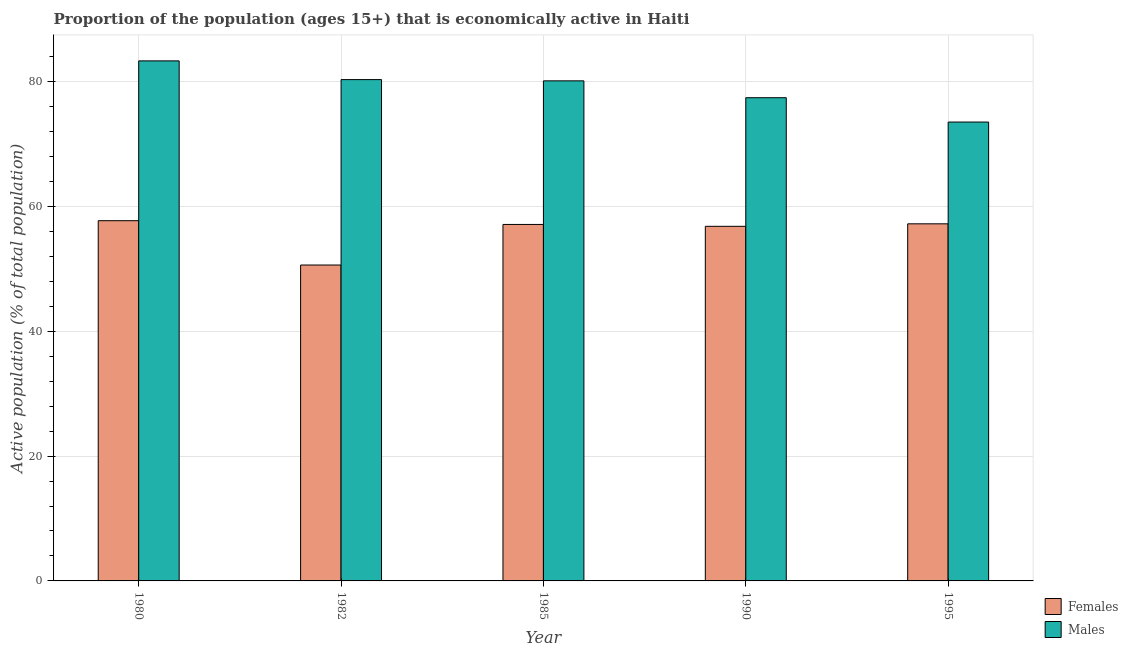How many different coloured bars are there?
Keep it short and to the point. 2. How many groups of bars are there?
Provide a succinct answer. 5. Are the number of bars per tick equal to the number of legend labels?
Offer a very short reply. Yes. Are the number of bars on each tick of the X-axis equal?
Your answer should be very brief. Yes. What is the label of the 4th group of bars from the left?
Your response must be concise. 1990. In how many cases, is the number of bars for a given year not equal to the number of legend labels?
Offer a very short reply. 0. What is the percentage of economically active female population in 1980?
Ensure brevity in your answer.  57.7. Across all years, what is the maximum percentage of economically active female population?
Your response must be concise. 57.7. Across all years, what is the minimum percentage of economically active female population?
Give a very brief answer. 50.6. In which year was the percentage of economically active female population maximum?
Your answer should be compact. 1980. What is the total percentage of economically active female population in the graph?
Your response must be concise. 279.4. What is the difference between the percentage of economically active male population in 1995 and the percentage of economically active female population in 1980?
Your response must be concise. -9.8. What is the average percentage of economically active female population per year?
Provide a short and direct response. 55.88. In the year 1985, what is the difference between the percentage of economically active male population and percentage of economically active female population?
Give a very brief answer. 0. In how many years, is the percentage of economically active male population greater than 60 %?
Your response must be concise. 5. What is the ratio of the percentage of economically active female population in 1982 to that in 1990?
Keep it short and to the point. 0.89. Is the percentage of economically active male population in 1980 less than that in 1985?
Ensure brevity in your answer.  No. What is the difference between the highest and the lowest percentage of economically active female population?
Make the answer very short. 7.1. What does the 1st bar from the left in 1995 represents?
Keep it short and to the point. Females. What does the 2nd bar from the right in 1990 represents?
Ensure brevity in your answer.  Females. How many bars are there?
Keep it short and to the point. 10. What is the difference between two consecutive major ticks on the Y-axis?
Your response must be concise. 20. Are the values on the major ticks of Y-axis written in scientific E-notation?
Your answer should be compact. No. Does the graph contain any zero values?
Give a very brief answer. No. Where does the legend appear in the graph?
Your response must be concise. Bottom right. How are the legend labels stacked?
Provide a succinct answer. Vertical. What is the title of the graph?
Offer a terse response. Proportion of the population (ages 15+) that is economically active in Haiti. What is the label or title of the Y-axis?
Your response must be concise. Active population (% of total population). What is the Active population (% of total population) in Females in 1980?
Provide a short and direct response. 57.7. What is the Active population (% of total population) of Males in 1980?
Your answer should be very brief. 83.3. What is the Active population (% of total population) of Females in 1982?
Provide a short and direct response. 50.6. What is the Active population (% of total population) of Males in 1982?
Give a very brief answer. 80.3. What is the Active population (% of total population) of Females in 1985?
Ensure brevity in your answer.  57.1. What is the Active population (% of total population) in Males in 1985?
Keep it short and to the point. 80.1. What is the Active population (% of total population) in Females in 1990?
Ensure brevity in your answer.  56.8. What is the Active population (% of total population) in Males in 1990?
Your answer should be very brief. 77.4. What is the Active population (% of total population) in Females in 1995?
Provide a short and direct response. 57.2. What is the Active population (% of total population) of Males in 1995?
Ensure brevity in your answer.  73.5. Across all years, what is the maximum Active population (% of total population) of Females?
Offer a terse response. 57.7. Across all years, what is the maximum Active population (% of total population) of Males?
Your answer should be very brief. 83.3. Across all years, what is the minimum Active population (% of total population) in Females?
Make the answer very short. 50.6. Across all years, what is the minimum Active population (% of total population) of Males?
Your response must be concise. 73.5. What is the total Active population (% of total population) of Females in the graph?
Keep it short and to the point. 279.4. What is the total Active population (% of total population) of Males in the graph?
Give a very brief answer. 394.6. What is the difference between the Active population (% of total population) of Females in 1980 and that in 1982?
Offer a terse response. 7.1. What is the difference between the Active population (% of total population) in Males in 1980 and that in 1982?
Make the answer very short. 3. What is the difference between the Active population (% of total population) in Females in 1980 and that in 1990?
Offer a very short reply. 0.9. What is the difference between the Active population (% of total population) of Males in 1980 and that in 1990?
Your answer should be compact. 5.9. What is the difference between the Active population (% of total population) of Females in 1980 and that in 1995?
Provide a short and direct response. 0.5. What is the difference between the Active population (% of total population) of Males in 1982 and that in 1985?
Make the answer very short. 0.2. What is the difference between the Active population (% of total population) of Females in 1982 and that in 1990?
Make the answer very short. -6.2. What is the difference between the Active population (% of total population) in Females in 1985 and that in 1990?
Give a very brief answer. 0.3. What is the difference between the Active population (% of total population) in Males in 1985 and that in 1990?
Provide a succinct answer. 2.7. What is the difference between the Active population (% of total population) in Females in 1990 and that in 1995?
Keep it short and to the point. -0.4. What is the difference between the Active population (% of total population) in Males in 1990 and that in 1995?
Offer a very short reply. 3.9. What is the difference between the Active population (% of total population) in Females in 1980 and the Active population (% of total population) in Males in 1982?
Provide a succinct answer. -22.6. What is the difference between the Active population (% of total population) in Females in 1980 and the Active population (% of total population) in Males in 1985?
Provide a succinct answer. -22.4. What is the difference between the Active population (% of total population) of Females in 1980 and the Active population (% of total population) of Males in 1990?
Your answer should be very brief. -19.7. What is the difference between the Active population (% of total population) in Females in 1980 and the Active population (% of total population) in Males in 1995?
Your answer should be very brief. -15.8. What is the difference between the Active population (% of total population) of Females in 1982 and the Active population (% of total population) of Males in 1985?
Offer a terse response. -29.5. What is the difference between the Active population (% of total population) in Females in 1982 and the Active population (% of total population) in Males in 1990?
Your answer should be compact. -26.8. What is the difference between the Active population (% of total population) of Females in 1982 and the Active population (% of total population) of Males in 1995?
Offer a terse response. -22.9. What is the difference between the Active population (% of total population) in Females in 1985 and the Active population (% of total population) in Males in 1990?
Your answer should be compact. -20.3. What is the difference between the Active population (% of total population) of Females in 1985 and the Active population (% of total population) of Males in 1995?
Keep it short and to the point. -16.4. What is the difference between the Active population (% of total population) of Females in 1990 and the Active population (% of total population) of Males in 1995?
Ensure brevity in your answer.  -16.7. What is the average Active population (% of total population) in Females per year?
Your response must be concise. 55.88. What is the average Active population (% of total population) of Males per year?
Ensure brevity in your answer.  78.92. In the year 1980, what is the difference between the Active population (% of total population) in Females and Active population (% of total population) in Males?
Your answer should be very brief. -25.6. In the year 1982, what is the difference between the Active population (% of total population) in Females and Active population (% of total population) in Males?
Offer a terse response. -29.7. In the year 1990, what is the difference between the Active population (% of total population) in Females and Active population (% of total population) in Males?
Provide a short and direct response. -20.6. In the year 1995, what is the difference between the Active population (% of total population) of Females and Active population (% of total population) of Males?
Offer a terse response. -16.3. What is the ratio of the Active population (% of total population) in Females in 1980 to that in 1982?
Your answer should be very brief. 1.14. What is the ratio of the Active population (% of total population) in Males in 1980 to that in 1982?
Offer a very short reply. 1.04. What is the ratio of the Active population (% of total population) of Females in 1980 to that in 1985?
Your answer should be compact. 1.01. What is the ratio of the Active population (% of total population) of Females in 1980 to that in 1990?
Keep it short and to the point. 1.02. What is the ratio of the Active population (% of total population) of Males in 1980 to that in 1990?
Provide a short and direct response. 1.08. What is the ratio of the Active population (% of total population) of Females in 1980 to that in 1995?
Ensure brevity in your answer.  1.01. What is the ratio of the Active population (% of total population) of Males in 1980 to that in 1995?
Give a very brief answer. 1.13. What is the ratio of the Active population (% of total population) in Females in 1982 to that in 1985?
Your answer should be compact. 0.89. What is the ratio of the Active population (% of total population) in Males in 1982 to that in 1985?
Give a very brief answer. 1. What is the ratio of the Active population (% of total population) in Females in 1982 to that in 1990?
Your answer should be very brief. 0.89. What is the ratio of the Active population (% of total population) of Males in 1982 to that in 1990?
Give a very brief answer. 1.04. What is the ratio of the Active population (% of total population) of Females in 1982 to that in 1995?
Ensure brevity in your answer.  0.88. What is the ratio of the Active population (% of total population) of Males in 1982 to that in 1995?
Provide a short and direct response. 1.09. What is the ratio of the Active population (% of total population) of Males in 1985 to that in 1990?
Make the answer very short. 1.03. What is the ratio of the Active population (% of total population) in Males in 1985 to that in 1995?
Keep it short and to the point. 1.09. What is the ratio of the Active population (% of total population) of Females in 1990 to that in 1995?
Offer a terse response. 0.99. What is the ratio of the Active population (% of total population) in Males in 1990 to that in 1995?
Give a very brief answer. 1.05. 